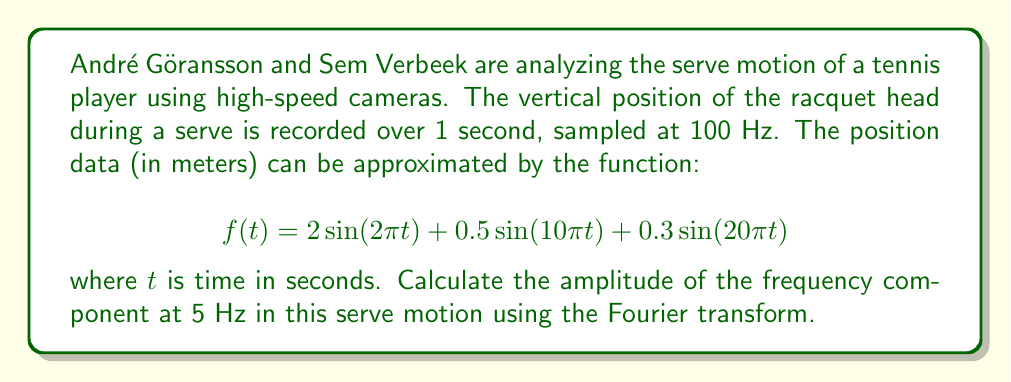Give your solution to this math problem. To solve this problem, we'll follow these steps:

1) First, recall that the Fourier transform of a continuous-time signal $f(t)$ is given by:

   $$F(\omega) = \int_{-\infty}^{\infty} f(t) e^{-i\omega t} dt$$

   where $\omega = 2\pi f$ and $f$ is the frequency in Hz.

2) Our signal $f(t)$ consists of three sinusoidal components:

   $$f(t) = 2 \sin(2\pi t) + 0.5 \sin(10\pi t) + 0.3 \sin(20\pi t)$$

3) We can use the linearity property of the Fourier transform and the known transform of sine functions:

   $$\mathcal{F}\{\sin(\omega_0 t)\} = \frac{i}{2}[\delta(\omega + \omega_0) - \delta(\omega - \omega_0)]$$

4) Applying this to our signal:

   $$F(\omega) = 2\cdot\frac{i}{2}[\delta(\omega + 2\pi) - \delta(\omega - 2\pi)] + $$
   $$0.5\cdot\frac{i}{2}[\delta(\omega + 10\pi) - \delta(\omega - 10\pi)] + $$
   $$0.3\cdot\frac{i}{2}[\delta(\omega + 20\pi) - \delta(\omega - 20\pi)]$$

5) The amplitude of each frequency component is given by the absolute value of its coefficient in the Fourier transform.

6) We're asked about the 5 Hz component. Note that $\omega = 2\pi f = 2\pi \cdot 5 = 10\pi$ for 5 Hz.

7) Looking at our Fourier transform, we see that the 5 Hz component corresponds to the second term, with a coefficient of 0.5.

8) Therefore, the amplitude of the 5 Hz component is 0.5.
Answer: The amplitude of the 5 Hz frequency component in the serve motion is 0.5 meters. 